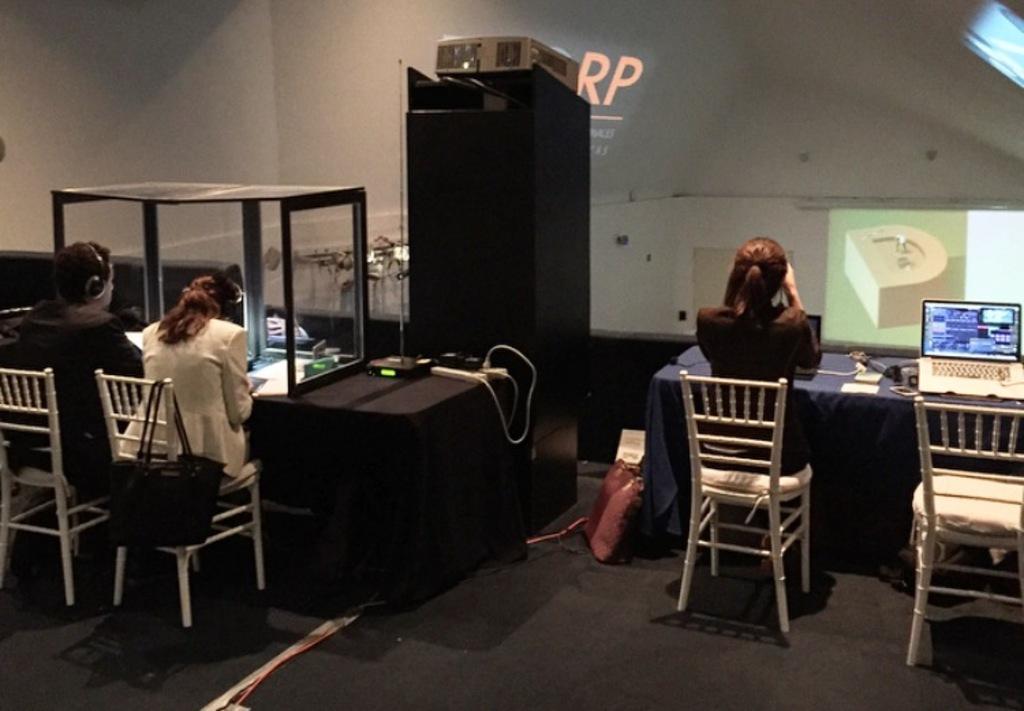Describe this image in one or two sentences. Two women and a man sitting in the room which has four chairs and two tables, laptop and a projector for screening and also the socket used for the connection. And the women are wearing the black and white suits and also two hand bags which are pink and black in color and the chairs are white in color, The floor mat which is black in color and also we have the table mat which is blue in color. 